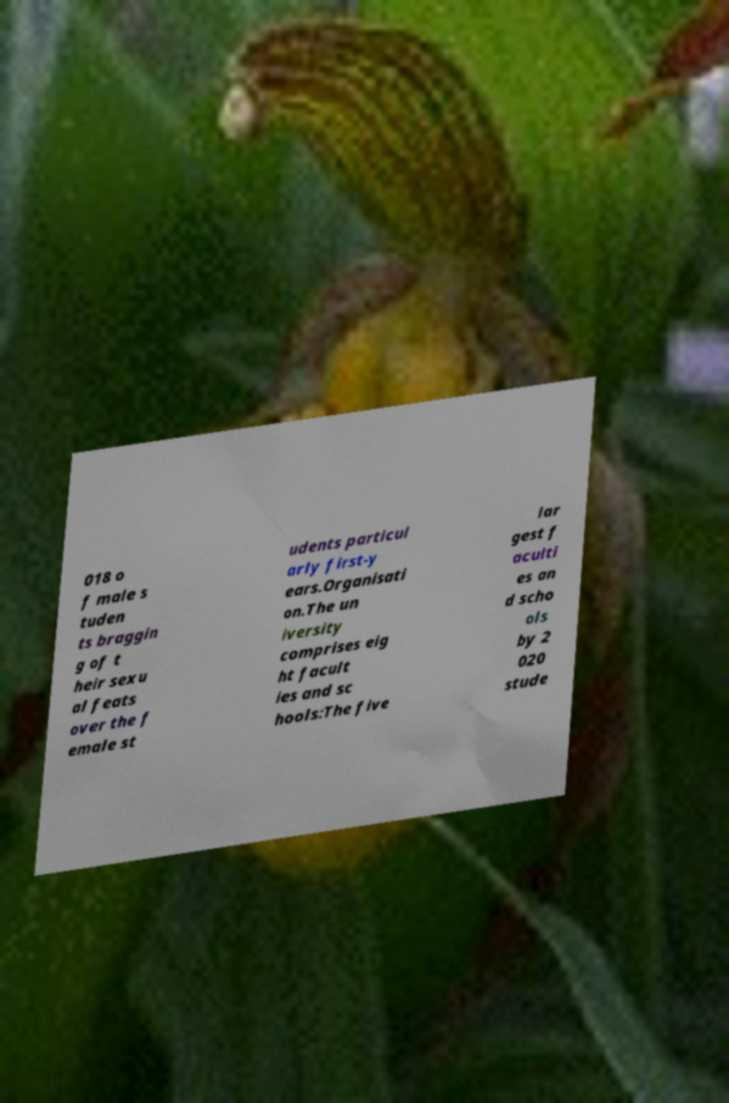For documentation purposes, I need the text within this image transcribed. Could you provide that? 018 o f male s tuden ts braggin g of t heir sexu al feats over the f emale st udents particul arly first-y ears.Organisati on.The un iversity comprises eig ht facult ies and sc hools:The five lar gest f aculti es an d scho ols by 2 020 stude 